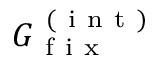<formula> <loc_0><loc_0><loc_500><loc_500>G _ { f i x } ^ { ( i n t ) }</formula> 